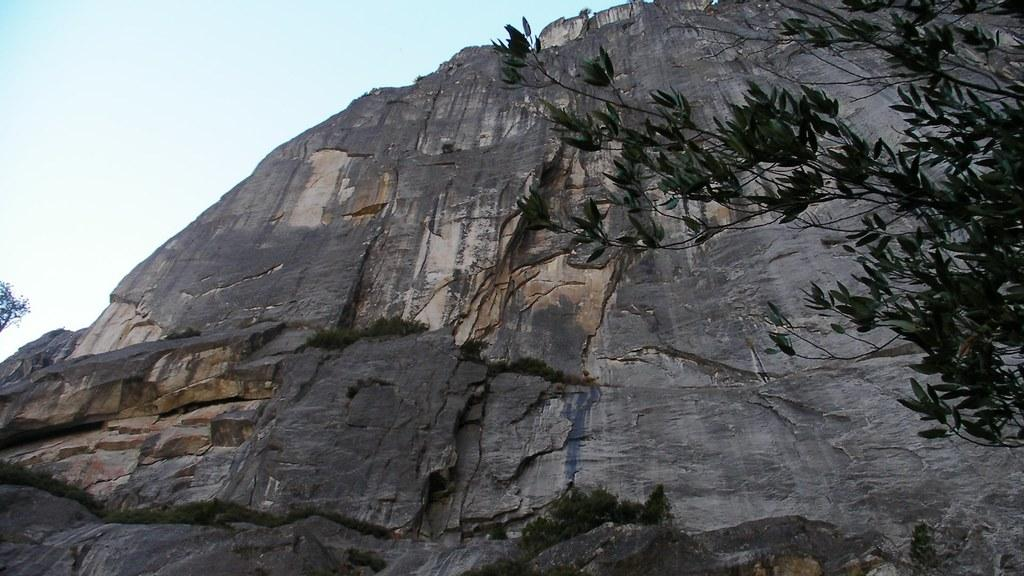What type of vegetation can be seen in the image? There are trees in the image. What is located behind the trees? There is a hill behind the trees. What is visible at the top of the image? Clouds are visible at the top of the image. What else can be seen in the sky? The sky is visible in the image. Reasoning: Let'g: Let's think step by step in order to produce the conversation. We start by identifying the main subject in the image, which is the trees. Then, we expand the conversation to include other elements that are also visible, such as the hill, clouds, and sky. Each question is designed to elicit a specific detail about the image that is known from the provided facts. Absurd Question/Answer: What type of chess piece is located on the hill in the image? There is no chess piece present in the image; it features trees, a hill, clouds, and the sky. What color is the skirt worn by the tree in the image? Trees do not wear skirts, and there is no clothing item present in the image. 